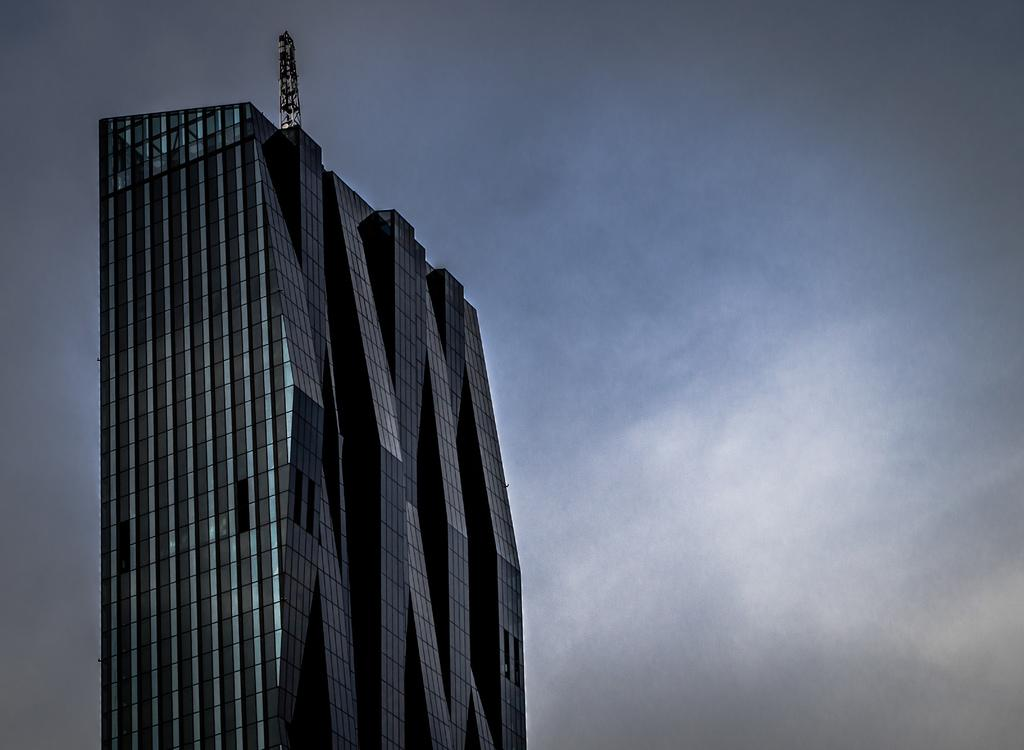What type of structure is present in the image? There is a building in the image. What part of the natural environment can be seen in the image? The sky is visible in the image. How many fingers can be seen on the glove in the image? There is no glove present in the image, so it is not possible to determine the number of fingers on a glove. 